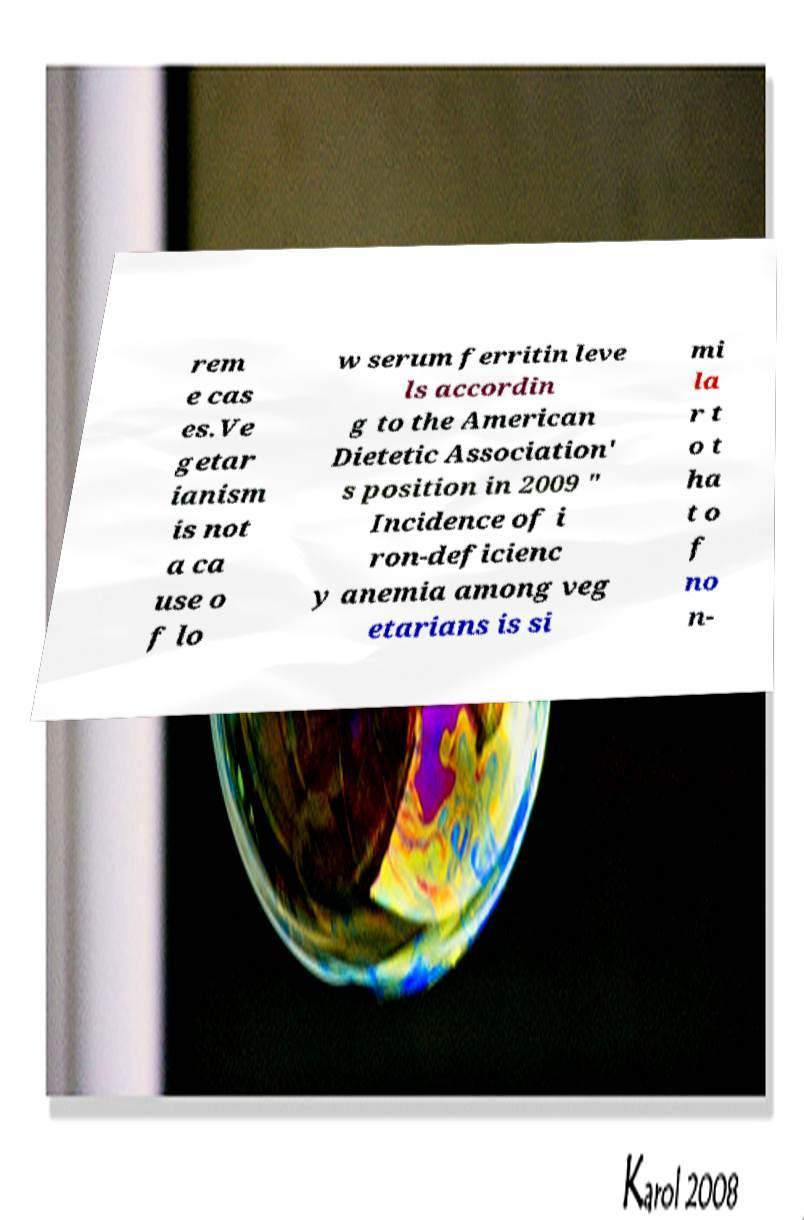Can you accurately transcribe the text from the provided image for me? rem e cas es.Ve getar ianism is not a ca use o f lo w serum ferritin leve ls accordin g to the American Dietetic Association' s position in 2009 " Incidence of i ron-deficienc y anemia among veg etarians is si mi la r t o t ha t o f no n- 